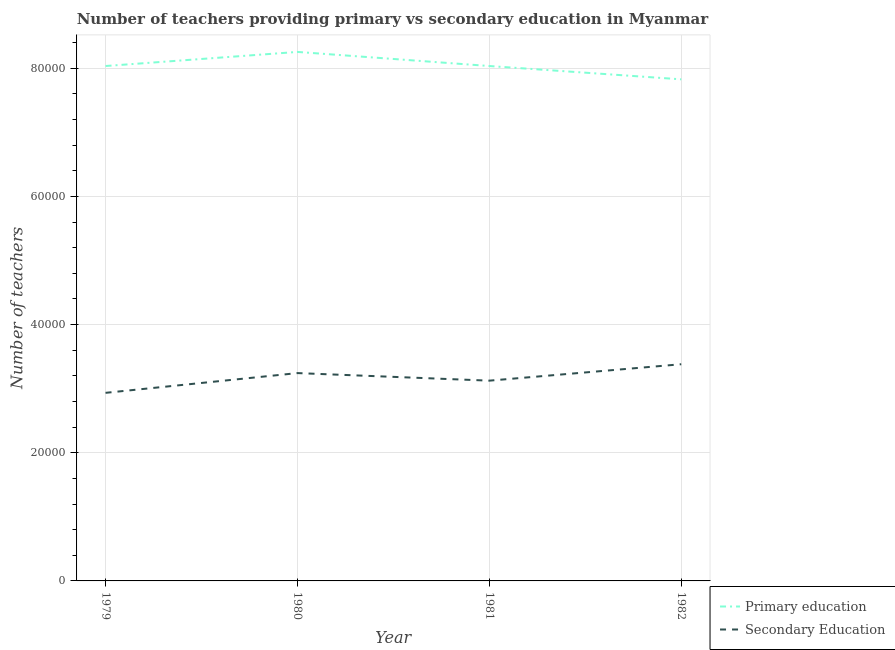How many different coloured lines are there?
Offer a terse response. 2. Is the number of lines equal to the number of legend labels?
Your answer should be compact. Yes. What is the number of primary teachers in 1981?
Keep it short and to the point. 8.03e+04. Across all years, what is the maximum number of secondary teachers?
Provide a succinct answer. 3.38e+04. Across all years, what is the minimum number of primary teachers?
Keep it short and to the point. 7.83e+04. In which year was the number of primary teachers maximum?
Offer a terse response. 1980. In which year was the number of primary teachers minimum?
Provide a succinct answer. 1982. What is the total number of primary teachers in the graph?
Your answer should be very brief. 3.21e+05. What is the difference between the number of primary teachers in 1981 and that in 1982?
Your answer should be compact. 2078. What is the difference between the number of primary teachers in 1979 and the number of secondary teachers in 1980?
Offer a terse response. 4.79e+04. What is the average number of primary teachers per year?
Provide a short and direct response. 8.04e+04. In the year 1979, what is the difference between the number of secondary teachers and number of primary teachers?
Offer a very short reply. -5.10e+04. In how many years, is the number of primary teachers greater than 4000?
Your response must be concise. 4. What is the ratio of the number of secondary teachers in 1980 to that in 1982?
Your answer should be compact. 0.96. What is the difference between the highest and the second highest number of primary teachers?
Keep it short and to the point. 2200. What is the difference between the highest and the lowest number of primary teachers?
Provide a short and direct response. 4278. In how many years, is the number of secondary teachers greater than the average number of secondary teachers taken over all years?
Give a very brief answer. 2. Does the number of secondary teachers monotonically increase over the years?
Make the answer very short. No. Is the number of secondary teachers strictly greater than the number of primary teachers over the years?
Offer a terse response. No. Is the number of primary teachers strictly less than the number of secondary teachers over the years?
Your answer should be very brief. No. How many lines are there?
Give a very brief answer. 2. What is the difference between two consecutive major ticks on the Y-axis?
Give a very brief answer. 2.00e+04. Does the graph contain any zero values?
Provide a short and direct response. No. Does the graph contain grids?
Offer a very short reply. Yes. Where does the legend appear in the graph?
Keep it short and to the point. Bottom right. How many legend labels are there?
Your response must be concise. 2. How are the legend labels stacked?
Your answer should be very brief. Vertical. What is the title of the graph?
Offer a very short reply. Number of teachers providing primary vs secondary education in Myanmar. Does "UN agencies" appear as one of the legend labels in the graph?
Ensure brevity in your answer.  No. What is the label or title of the X-axis?
Provide a succinct answer. Year. What is the label or title of the Y-axis?
Provide a succinct answer. Number of teachers. What is the Number of teachers of Primary education in 1979?
Provide a succinct answer. 8.03e+04. What is the Number of teachers of Secondary Education in 1979?
Offer a very short reply. 2.93e+04. What is the Number of teachers in Primary education in 1980?
Provide a short and direct response. 8.25e+04. What is the Number of teachers in Secondary Education in 1980?
Provide a succinct answer. 3.24e+04. What is the Number of teachers in Primary education in 1981?
Your answer should be compact. 8.03e+04. What is the Number of teachers of Secondary Education in 1981?
Offer a very short reply. 3.12e+04. What is the Number of teachers in Primary education in 1982?
Provide a succinct answer. 7.83e+04. What is the Number of teachers of Secondary Education in 1982?
Provide a succinct answer. 3.38e+04. Across all years, what is the maximum Number of teachers of Primary education?
Offer a terse response. 8.25e+04. Across all years, what is the maximum Number of teachers of Secondary Education?
Make the answer very short. 3.38e+04. Across all years, what is the minimum Number of teachers of Primary education?
Keep it short and to the point. 7.83e+04. Across all years, what is the minimum Number of teachers in Secondary Education?
Provide a succinct answer. 2.93e+04. What is the total Number of teachers in Primary education in the graph?
Offer a very short reply. 3.21e+05. What is the total Number of teachers of Secondary Education in the graph?
Offer a very short reply. 1.27e+05. What is the difference between the Number of teachers in Primary education in 1979 and that in 1980?
Offer a very short reply. -2200. What is the difference between the Number of teachers in Secondary Education in 1979 and that in 1980?
Your answer should be very brief. -3082. What is the difference between the Number of teachers of Primary education in 1979 and that in 1981?
Keep it short and to the point. 0. What is the difference between the Number of teachers in Secondary Education in 1979 and that in 1981?
Provide a short and direct response. -1900. What is the difference between the Number of teachers of Primary education in 1979 and that in 1982?
Provide a succinct answer. 2078. What is the difference between the Number of teachers in Secondary Education in 1979 and that in 1982?
Offer a very short reply. -4464. What is the difference between the Number of teachers of Primary education in 1980 and that in 1981?
Provide a short and direct response. 2200. What is the difference between the Number of teachers in Secondary Education in 1980 and that in 1981?
Your response must be concise. 1182. What is the difference between the Number of teachers in Primary education in 1980 and that in 1982?
Offer a very short reply. 4278. What is the difference between the Number of teachers of Secondary Education in 1980 and that in 1982?
Your answer should be very brief. -1382. What is the difference between the Number of teachers of Primary education in 1981 and that in 1982?
Make the answer very short. 2078. What is the difference between the Number of teachers in Secondary Education in 1981 and that in 1982?
Give a very brief answer. -2564. What is the difference between the Number of teachers of Primary education in 1979 and the Number of teachers of Secondary Education in 1980?
Your answer should be very brief. 4.79e+04. What is the difference between the Number of teachers in Primary education in 1979 and the Number of teachers in Secondary Education in 1981?
Offer a terse response. 4.91e+04. What is the difference between the Number of teachers of Primary education in 1979 and the Number of teachers of Secondary Education in 1982?
Provide a succinct answer. 4.65e+04. What is the difference between the Number of teachers in Primary education in 1980 and the Number of teachers in Secondary Education in 1981?
Give a very brief answer. 5.13e+04. What is the difference between the Number of teachers of Primary education in 1980 and the Number of teachers of Secondary Education in 1982?
Make the answer very short. 4.87e+04. What is the difference between the Number of teachers in Primary education in 1981 and the Number of teachers in Secondary Education in 1982?
Give a very brief answer. 4.65e+04. What is the average Number of teachers of Primary education per year?
Your answer should be compact. 8.04e+04. What is the average Number of teachers in Secondary Education per year?
Keep it short and to the point. 3.17e+04. In the year 1979, what is the difference between the Number of teachers in Primary education and Number of teachers in Secondary Education?
Make the answer very short. 5.10e+04. In the year 1980, what is the difference between the Number of teachers in Primary education and Number of teachers in Secondary Education?
Ensure brevity in your answer.  5.01e+04. In the year 1981, what is the difference between the Number of teachers in Primary education and Number of teachers in Secondary Education?
Your answer should be compact. 4.91e+04. In the year 1982, what is the difference between the Number of teachers in Primary education and Number of teachers in Secondary Education?
Your answer should be very brief. 4.45e+04. What is the ratio of the Number of teachers of Primary education in 1979 to that in 1980?
Offer a very short reply. 0.97. What is the ratio of the Number of teachers in Secondary Education in 1979 to that in 1980?
Give a very brief answer. 0.91. What is the ratio of the Number of teachers of Primary education in 1979 to that in 1981?
Provide a short and direct response. 1. What is the ratio of the Number of teachers in Secondary Education in 1979 to that in 1981?
Keep it short and to the point. 0.94. What is the ratio of the Number of teachers of Primary education in 1979 to that in 1982?
Give a very brief answer. 1.03. What is the ratio of the Number of teachers of Secondary Education in 1979 to that in 1982?
Your answer should be very brief. 0.87. What is the ratio of the Number of teachers of Primary education in 1980 to that in 1981?
Offer a terse response. 1.03. What is the ratio of the Number of teachers in Secondary Education in 1980 to that in 1981?
Your answer should be compact. 1.04. What is the ratio of the Number of teachers of Primary education in 1980 to that in 1982?
Offer a very short reply. 1.05. What is the ratio of the Number of teachers in Secondary Education in 1980 to that in 1982?
Your response must be concise. 0.96. What is the ratio of the Number of teachers of Primary education in 1981 to that in 1982?
Ensure brevity in your answer.  1.03. What is the ratio of the Number of teachers of Secondary Education in 1981 to that in 1982?
Provide a short and direct response. 0.92. What is the difference between the highest and the second highest Number of teachers in Primary education?
Give a very brief answer. 2200. What is the difference between the highest and the second highest Number of teachers in Secondary Education?
Make the answer very short. 1382. What is the difference between the highest and the lowest Number of teachers in Primary education?
Make the answer very short. 4278. What is the difference between the highest and the lowest Number of teachers in Secondary Education?
Provide a succinct answer. 4464. 